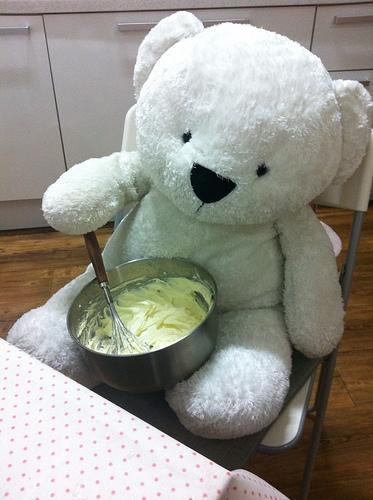How many bears?
Give a very brief answer. 1. How many silver handles are visible?
Give a very brief answer. 5. 